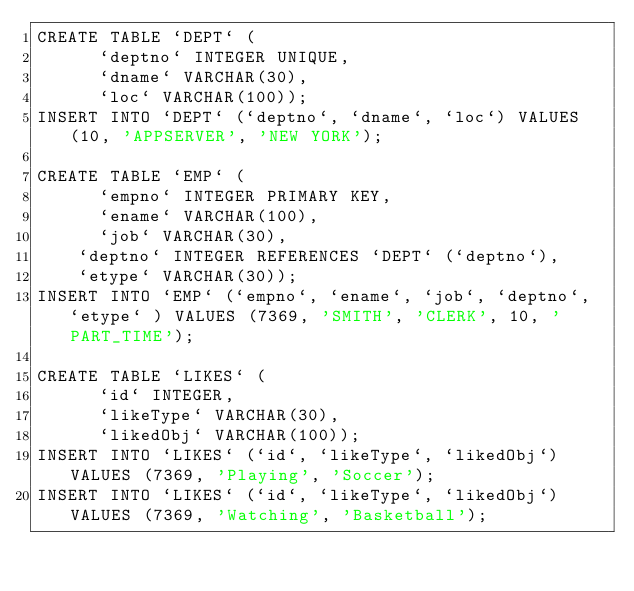Convert code to text. <code><loc_0><loc_0><loc_500><loc_500><_SQL_>CREATE TABLE `DEPT` (
      `deptno` INTEGER UNIQUE,
      `dname` VARCHAR(30),
      `loc` VARCHAR(100));
INSERT INTO `DEPT` (`deptno`, `dname`, `loc`) VALUES (10, 'APPSERVER', 'NEW YORK');

CREATE TABLE `EMP` (
      `empno` INTEGER PRIMARY KEY,
      `ename` VARCHAR(100),
      `job` VARCHAR(30),
	  `deptno` INTEGER REFERENCES `DEPT` (`deptno`),
	  `etype` VARCHAR(30));
INSERT INTO `EMP` (`empno`, `ename`, `job`, `deptno`, `etype` ) VALUES (7369, 'SMITH', 'CLERK', 10, 'PART_TIME');

CREATE TABLE `LIKES` (
      `id` INTEGER,
      `likeType` VARCHAR(30),
      `likedObj` VARCHAR(100));
INSERT INTO `LIKES` (`id`, `likeType`, `likedObj`) VALUES (7369, 'Playing', 'Soccer');
INSERT INTO `LIKES` (`id`, `likeType`, `likedObj`) VALUES (7369, 'Watching', 'Basketball');</code> 